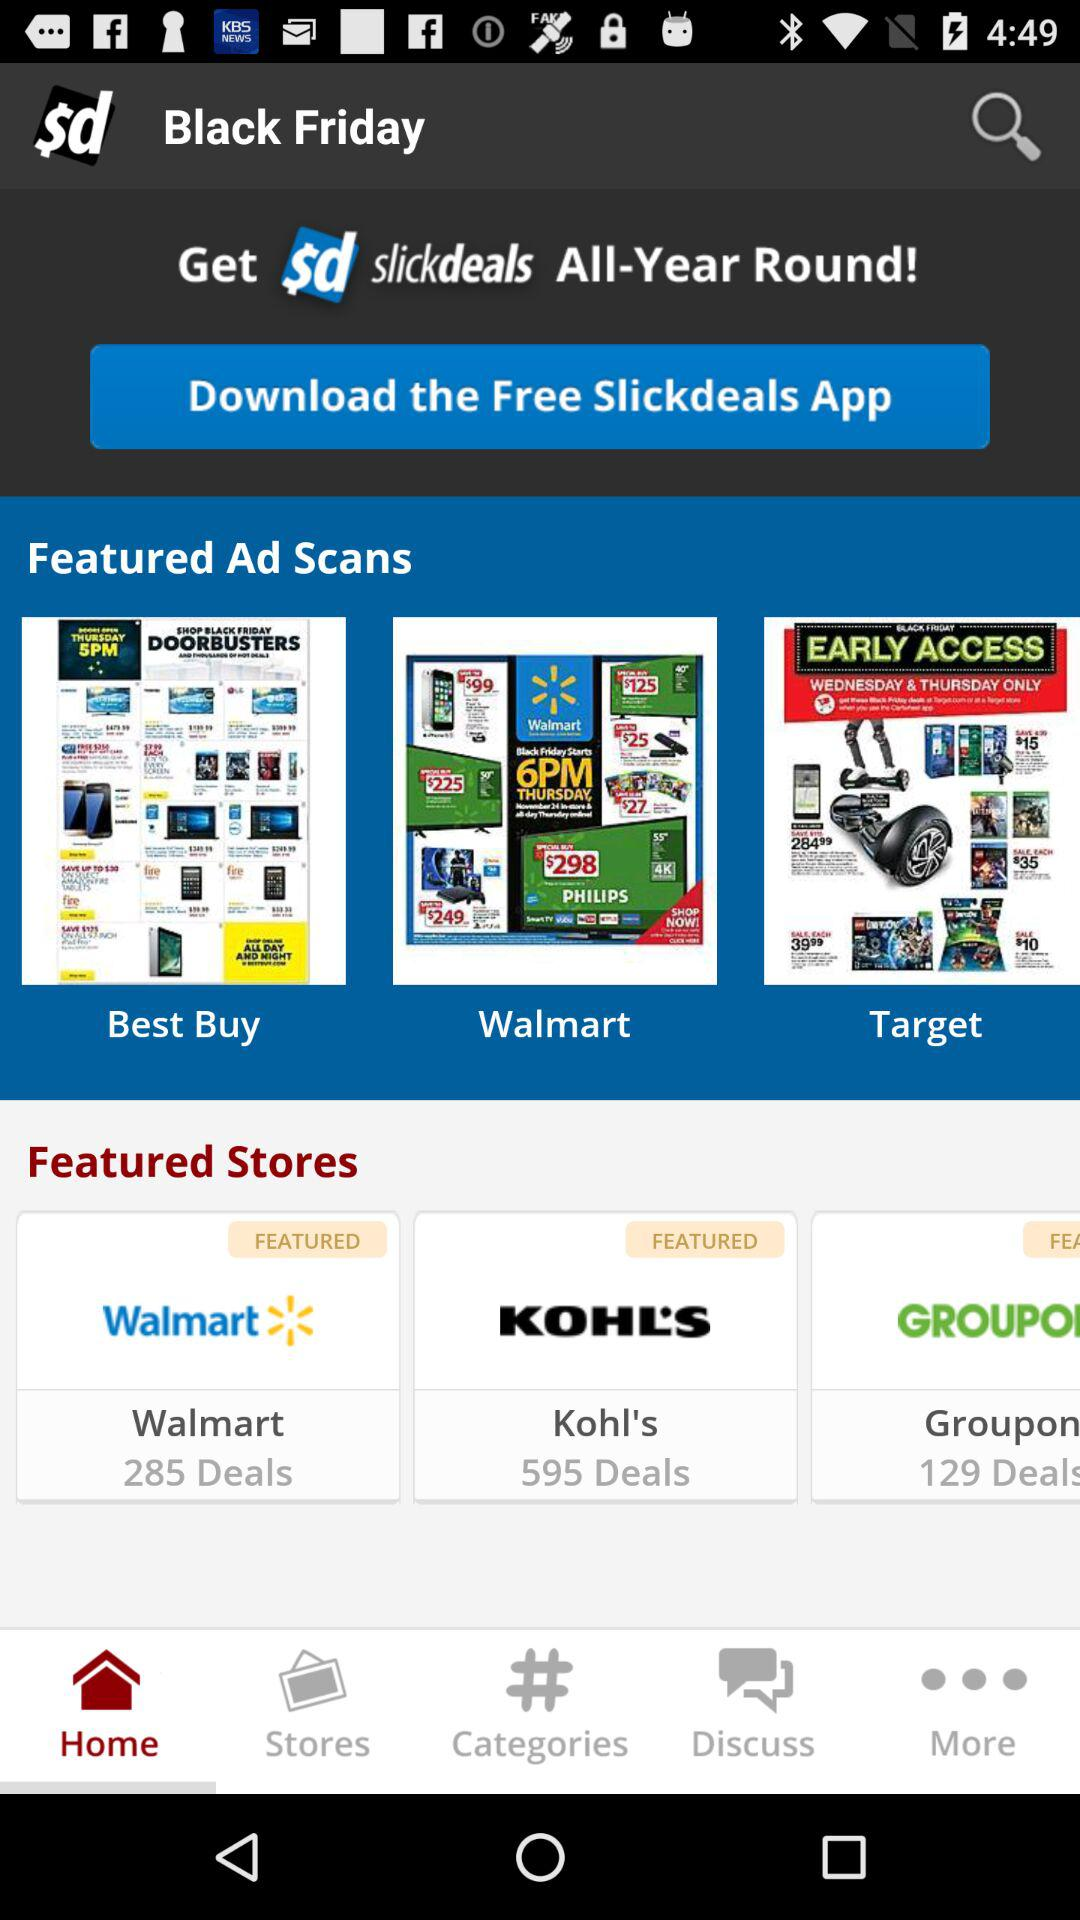Which tab is selected? The selected tab is "Home". 